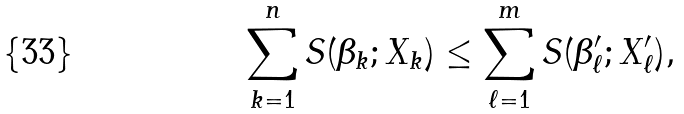Convert formula to latex. <formula><loc_0><loc_0><loc_500><loc_500>\sum _ { k = 1 } ^ { n } S ( \beta _ { k } ; X _ { k } ) \leq \sum _ { \ell = 1 } ^ { m } S ( \beta ^ { \prime } _ { \ell } ; X ^ { \prime } _ { \ell } ) ,</formula> 